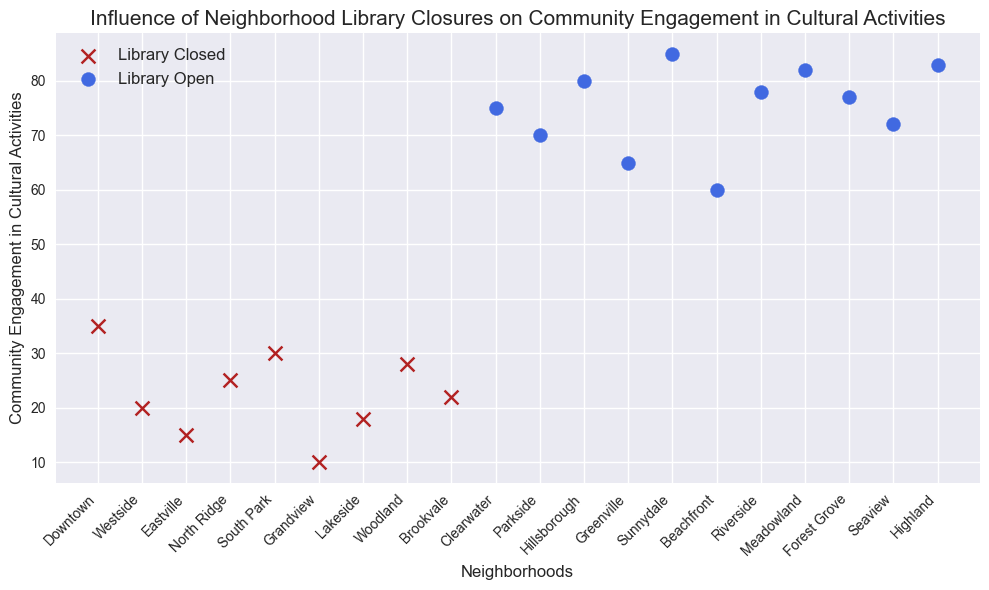Which neighborhood has the least community engagement in cultural activities? The neighborhood with the lowest value on the y-axis (Community Engagement in Cultural Activities) is Parkside.
Answer: Parkside Which neighborhood has the highest community engagement in cultural activities? The neighborhood with the highest value on the y-axis (Community Engagement in Cultural Activities) is Clearwater.
Answer: Clearwater Are neighborhoods with open libraries generally more engaged in cultural activities than those with closed libraries? By observing the plot, most of the blue circles (open libraries) are higher on the y-axis compared to the red x's (closed libraries), indicating higher community engagement.
Answer: Yes Which neighborhoods have exactly 20 and 25 points of community engagement, respectively? The y-axis shows that Eastville has 20 points and Lakeside has 25 points of community engagement.
Answer: Eastville and Lakeside How many neighborhoods have their libraries closed? Count the number of red x's on the plot to find the number of neighborhoods with closed libraries. There are 8 red x's.
Answer: 8 Compare the community engagement in cultural activities between Downtown and Greenville. Downtown (closed library) has 35 points, while Greenville (open library) has 78 points on the y-axis. Greenville has higher engagement.
Answer: Greenville What is the average community engagement in cultural activities for neighborhoods with closed libraries? Add the engagement values for neighborhoods with closed libraries (35 + 20 + 15 + 25 + 30 + 10 + 18 + 28 + 22) = 203 and divide by the number of neighborhoods (9). 203 / 9 = 22.56.
Answer: 22.56 Which neighborhoods have similar levels of community engagement despite differing library statuses? By comparison, Grandview and Riverside both have high community engagement levels (80 and 77), even though both have open libraries. There are no such pairs from different library statuses that match closely.
Answer: None What's the difference in community engagement between the highest and lowest engagement neighborhoods? The highest engagement is at Clearwater (85), and the lowest is at Parkside (10). The difference is 85 - 10 = 75.
Answer: 75 Is there any neighborhood with a closed library that has higher community engagement than an open library neighborhood? By comparing red x's and blue circles, no red x's have a higher y-axis value than any blue circles.
Answer: No 